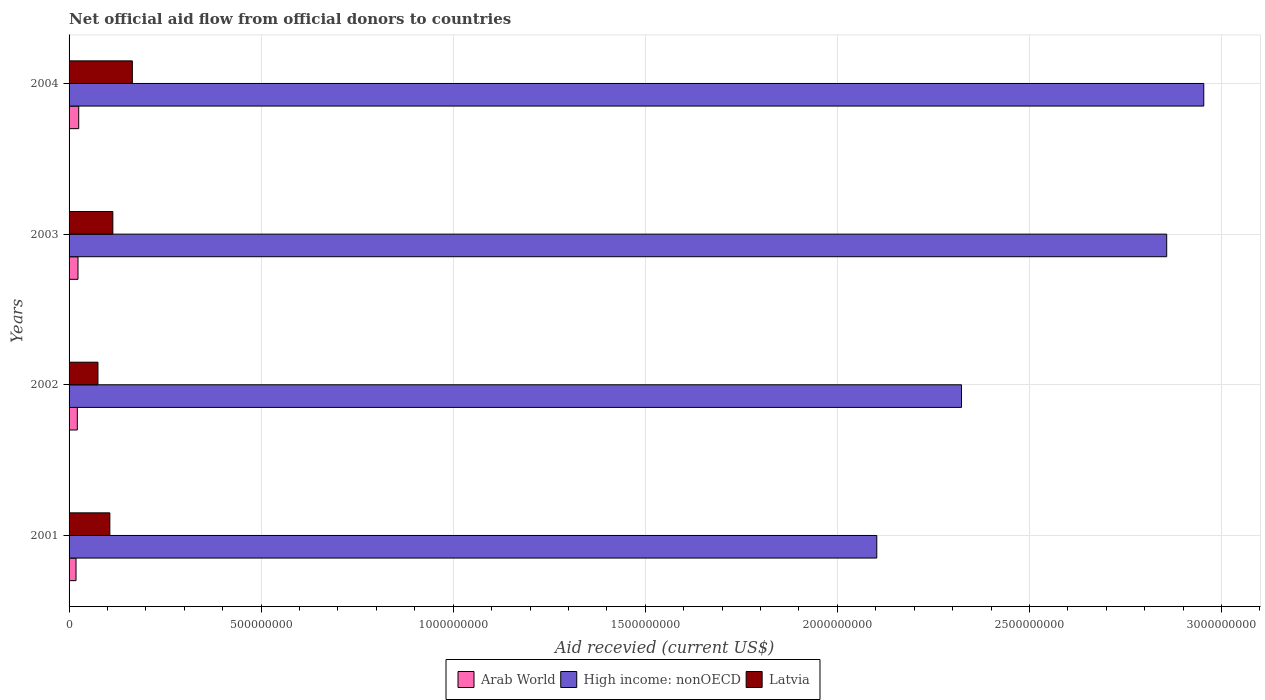How many groups of bars are there?
Provide a succinct answer. 4. Are the number of bars per tick equal to the number of legend labels?
Make the answer very short. Yes. Are the number of bars on each tick of the Y-axis equal?
Your answer should be compact. Yes. How many bars are there on the 1st tick from the top?
Your answer should be compact. 3. In how many cases, is the number of bars for a given year not equal to the number of legend labels?
Ensure brevity in your answer.  0. What is the total aid received in Arab World in 2001?
Keep it short and to the point. 1.81e+07. Across all years, what is the maximum total aid received in Arab World?
Provide a short and direct response. 2.51e+07. Across all years, what is the minimum total aid received in Latvia?
Provide a succinct answer. 7.52e+07. In which year was the total aid received in Arab World minimum?
Your answer should be very brief. 2001. What is the total total aid received in High income: nonOECD in the graph?
Offer a very short reply. 1.02e+1. What is the difference between the total aid received in Arab World in 2003 and that in 2004?
Your answer should be compact. -1.86e+06. What is the difference between the total aid received in High income: nonOECD in 2001 and the total aid received in Arab World in 2003?
Offer a terse response. 2.08e+09. What is the average total aid received in Arab World per year?
Keep it short and to the point. 2.20e+07. In the year 2004, what is the difference between the total aid received in High income: nonOECD and total aid received in Latvia?
Offer a very short reply. 2.79e+09. What is the ratio of the total aid received in Latvia in 2003 to that in 2004?
Ensure brevity in your answer.  0.69. Is the total aid received in Latvia in 2001 less than that in 2003?
Provide a succinct answer. Yes. What is the difference between the highest and the second highest total aid received in Arab World?
Keep it short and to the point. 1.86e+06. What is the difference between the highest and the lowest total aid received in High income: nonOECD?
Your answer should be very brief. 8.51e+08. Is the sum of the total aid received in Latvia in 2001 and 2004 greater than the maximum total aid received in High income: nonOECD across all years?
Your answer should be compact. No. What does the 2nd bar from the top in 2002 represents?
Make the answer very short. High income: nonOECD. What does the 1st bar from the bottom in 2004 represents?
Offer a very short reply. Arab World. How many bars are there?
Keep it short and to the point. 12. Where does the legend appear in the graph?
Your answer should be compact. Bottom center. How many legend labels are there?
Ensure brevity in your answer.  3. What is the title of the graph?
Give a very brief answer. Net official aid flow from official donors to countries. What is the label or title of the X-axis?
Keep it short and to the point. Aid recevied (current US$). What is the Aid recevied (current US$) in Arab World in 2001?
Offer a terse response. 1.81e+07. What is the Aid recevied (current US$) of High income: nonOECD in 2001?
Offer a very short reply. 2.10e+09. What is the Aid recevied (current US$) of Latvia in 2001?
Your answer should be very brief. 1.06e+08. What is the Aid recevied (current US$) of Arab World in 2002?
Ensure brevity in your answer.  2.14e+07. What is the Aid recevied (current US$) in High income: nonOECD in 2002?
Make the answer very short. 2.32e+09. What is the Aid recevied (current US$) of Latvia in 2002?
Your answer should be compact. 7.52e+07. What is the Aid recevied (current US$) in Arab World in 2003?
Give a very brief answer. 2.32e+07. What is the Aid recevied (current US$) of High income: nonOECD in 2003?
Provide a short and direct response. 2.86e+09. What is the Aid recevied (current US$) of Latvia in 2003?
Offer a very short reply. 1.14e+08. What is the Aid recevied (current US$) in Arab World in 2004?
Offer a very short reply. 2.51e+07. What is the Aid recevied (current US$) in High income: nonOECD in 2004?
Provide a short and direct response. 2.95e+09. What is the Aid recevied (current US$) in Latvia in 2004?
Your response must be concise. 1.65e+08. Across all years, what is the maximum Aid recevied (current US$) in Arab World?
Offer a very short reply. 2.51e+07. Across all years, what is the maximum Aid recevied (current US$) in High income: nonOECD?
Provide a short and direct response. 2.95e+09. Across all years, what is the maximum Aid recevied (current US$) of Latvia?
Keep it short and to the point. 1.65e+08. Across all years, what is the minimum Aid recevied (current US$) in Arab World?
Your response must be concise. 1.81e+07. Across all years, what is the minimum Aid recevied (current US$) in High income: nonOECD?
Your response must be concise. 2.10e+09. Across all years, what is the minimum Aid recevied (current US$) of Latvia?
Give a very brief answer. 7.52e+07. What is the total Aid recevied (current US$) in Arab World in the graph?
Give a very brief answer. 8.79e+07. What is the total Aid recevied (current US$) of High income: nonOECD in the graph?
Provide a succinct answer. 1.02e+1. What is the total Aid recevied (current US$) in Latvia in the graph?
Your answer should be compact. 4.60e+08. What is the difference between the Aid recevied (current US$) of Arab World in 2001 and that in 2002?
Offer a very short reply. -3.33e+06. What is the difference between the Aid recevied (current US$) of High income: nonOECD in 2001 and that in 2002?
Offer a very short reply. -2.21e+08. What is the difference between the Aid recevied (current US$) of Latvia in 2001 and that in 2002?
Keep it short and to the point. 3.09e+07. What is the difference between the Aid recevied (current US$) of Arab World in 2001 and that in 2003?
Offer a very short reply. -5.14e+06. What is the difference between the Aid recevied (current US$) of High income: nonOECD in 2001 and that in 2003?
Offer a terse response. -7.55e+08. What is the difference between the Aid recevied (current US$) in Latvia in 2001 and that in 2003?
Your answer should be very brief. -7.80e+06. What is the difference between the Aid recevied (current US$) of Arab World in 2001 and that in 2004?
Your answer should be very brief. -7.00e+06. What is the difference between the Aid recevied (current US$) of High income: nonOECD in 2001 and that in 2004?
Offer a very short reply. -8.51e+08. What is the difference between the Aid recevied (current US$) in Latvia in 2001 and that in 2004?
Your response must be concise. -5.86e+07. What is the difference between the Aid recevied (current US$) of Arab World in 2002 and that in 2003?
Provide a short and direct response. -1.81e+06. What is the difference between the Aid recevied (current US$) of High income: nonOECD in 2002 and that in 2003?
Provide a short and direct response. -5.34e+08. What is the difference between the Aid recevied (current US$) in Latvia in 2002 and that in 2003?
Make the answer very short. -3.87e+07. What is the difference between the Aid recevied (current US$) of Arab World in 2002 and that in 2004?
Give a very brief answer. -3.67e+06. What is the difference between the Aid recevied (current US$) in High income: nonOECD in 2002 and that in 2004?
Make the answer very short. -6.31e+08. What is the difference between the Aid recevied (current US$) of Latvia in 2002 and that in 2004?
Provide a short and direct response. -8.95e+07. What is the difference between the Aid recevied (current US$) in Arab World in 2003 and that in 2004?
Offer a terse response. -1.86e+06. What is the difference between the Aid recevied (current US$) of High income: nonOECD in 2003 and that in 2004?
Your answer should be compact. -9.65e+07. What is the difference between the Aid recevied (current US$) of Latvia in 2003 and that in 2004?
Your response must be concise. -5.08e+07. What is the difference between the Aid recevied (current US$) in Arab World in 2001 and the Aid recevied (current US$) in High income: nonOECD in 2002?
Ensure brevity in your answer.  -2.31e+09. What is the difference between the Aid recevied (current US$) of Arab World in 2001 and the Aid recevied (current US$) of Latvia in 2002?
Provide a short and direct response. -5.71e+07. What is the difference between the Aid recevied (current US$) of High income: nonOECD in 2001 and the Aid recevied (current US$) of Latvia in 2002?
Your response must be concise. 2.03e+09. What is the difference between the Aid recevied (current US$) of Arab World in 2001 and the Aid recevied (current US$) of High income: nonOECD in 2003?
Offer a very short reply. -2.84e+09. What is the difference between the Aid recevied (current US$) of Arab World in 2001 and the Aid recevied (current US$) of Latvia in 2003?
Ensure brevity in your answer.  -9.58e+07. What is the difference between the Aid recevied (current US$) of High income: nonOECD in 2001 and the Aid recevied (current US$) of Latvia in 2003?
Keep it short and to the point. 1.99e+09. What is the difference between the Aid recevied (current US$) of Arab World in 2001 and the Aid recevied (current US$) of High income: nonOECD in 2004?
Ensure brevity in your answer.  -2.94e+09. What is the difference between the Aid recevied (current US$) of Arab World in 2001 and the Aid recevied (current US$) of Latvia in 2004?
Ensure brevity in your answer.  -1.47e+08. What is the difference between the Aid recevied (current US$) of High income: nonOECD in 2001 and the Aid recevied (current US$) of Latvia in 2004?
Your answer should be very brief. 1.94e+09. What is the difference between the Aid recevied (current US$) of Arab World in 2002 and the Aid recevied (current US$) of High income: nonOECD in 2003?
Give a very brief answer. -2.84e+09. What is the difference between the Aid recevied (current US$) of Arab World in 2002 and the Aid recevied (current US$) of Latvia in 2003?
Provide a short and direct response. -9.25e+07. What is the difference between the Aid recevied (current US$) of High income: nonOECD in 2002 and the Aid recevied (current US$) of Latvia in 2003?
Your response must be concise. 2.21e+09. What is the difference between the Aid recevied (current US$) in Arab World in 2002 and the Aid recevied (current US$) in High income: nonOECD in 2004?
Ensure brevity in your answer.  -2.93e+09. What is the difference between the Aid recevied (current US$) of Arab World in 2002 and the Aid recevied (current US$) of Latvia in 2004?
Your response must be concise. -1.43e+08. What is the difference between the Aid recevied (current US$) in High income: nonOECD in 2002 and the Aid recevied (current US$) in Latvia in 2004?
Provide a succinct answer. 2.16e+09. What is the difference between the Aid recevied (current US$) in Arab World in 2003 and the Aid recevied (current US$) in High income: nonOECD in 2004?
Make the answer very short. -2.93e+09. What is the difference between the Aid recevied (current US$) in Arab World in 2003 and the Aid recevied (current US$) in Latvia in 2004?
Offer a terse response. -1.41e+08. What is the difference between the Aid recevied (current US$) in High income: nonOECD in 2003 and the Aid recevied (current US$) in Latvia in 2004?
Keep it short and to the point. 2.69e+09. What is the average Aid recevied (current US$) in Arab World per year?
Offer a terse response. 2.20e+07. What is the average Aid recevied (current US$) of High income: nonOECD per year?
Give a very brief answer. 2.56e+09. What is the average Aid recevied (current US$) of Latvia per year?
Provide a succinct answer. 1.15e+08. In the year 2001, what is the difference between the Aid recevied (current US$) of Arab World and Aid recevied (current US$) of High income: nonOECD?
Your response must be concise. -2.08e+09. In the year 2001, what is the difference between the Aid recevied (current US$) in Arab World and Aid recevied (current US$) in Latvia?
Your answer should be very brief. -8.80e+07. In the year 2001, what is the difference between the Aid recevied (current US$) of High income: nonOECD and Aid recevied (current US$) of Latvia?
Provide a succinct answer. 2.00e+09. In the year 2002, what is the difference between the Aid recevied (current US$) in Arab World and Aid recevied (current US$) in High income: nonOECD?
Offer a terse response. -2.30e+09. In the year 2002, what is the difference between the Aid recevied (current US$) in Arab World and Aid recevied (current US$) in Latvia?
Ensure brevity in your answer.  -5.38e+07. In the year 2002, what is the difference between the Aid recevied (current US$) of High income: nonOECD and Aid recevied (current US$) of Latvia?
Offer a very short reply. 2.25e+09. In the year 2003, what is the difference between the Aid recevied (current US$) of Arab World and Aid recevied (current US$) of High income: nonOECD?
Provide a short and direct response. -2.83e+09. In the year 2003, what is the difference between the Aid recevied (current US$) in Arab World and Aid recevied (current US$) in Latvia?
Give a very brief answer. -9.07e+07. In the year 2003, what is the difference between the Aid recevied (current US$) of High income: nonOECD and Aid recevied (current US$) of Latvia?
Give a very brief answer. 2.74e+09. In the year 2004, what is the difference between the Aid recevied (current US$) of Arab World and Aid recevied (current US$) of High income: nonOECD?
Keep it short and to the point. -2.93e+09. In the year 2004, what is the difference between the Aid recevied (current US$) in Arab World and Aid recevied (current US$) in Latvia?
Your response must be concise. -1.40e+08. In the year 2004, what is the difference between the Aid recevied (current US$) of High income: nonOECD and Aid recevied (current US$) of Latvia?
Your answer should be compact. 2.79e+09. What is the ratio of the Aid recevied (current US$) of Arab World in 2001 to that in 2002?
Your answer should be very brief. 0.84. What is the ratio of the Aid recevied (current US$) in High income: nonOECD in 2001 to that in 2002?
Make the answer very short. 0.91. What is the ratio of the Aid recevied (current US$) of Latvia in 2001 to that in 2002?
Your response must be concise. 1.41. What is the ratio of the Aid recevied (current US$) of Arab World in 2001 to that in 2003?
Your response must be concise. 0.78. What is the ratio of the Aid recevied (current US$) in High income: nonOECD in 2001 to that in 2003?
Provide a short and direct response. 0.74. What is the ratio of the Aid recevied (current US$) of Latvia in 2001 to that in 2003?
Provide a short and direct response. 0.93. What is the ratio of the Aid recevied (current US$) in Arab World in 2001 to that in 2004?
Provide a succinct answer. 0.72. What is the ratio of the Aid recevied (current US$) of High income: nonOECD in 2001 to that in 2004?
Your answer should be very brief. 0.71. What is the ratio of the Aid recevied (current US$) of Latvia in 2001 to that in 2004?
Give a very brief answer. 0.64. What is the ratio of the Aid recevied (current US$) in Arab World in 2002 to that in 2003?
Provide a succinct answer. 0.92. What is the ratio of the Aid recevied (current US$) of High income: nonOECD in 2002 to that in 2003?
Offer a terse response. 0.81. What is the ratio of the Aid recevied (current US$) in Latvia in 2002 to that in 2003?
Your answer should be compact. 0.66. What is the ratio of the Aid recevied (current US$) of Arab World in 2002 to that in 2004?
Your answer should be compact. 0.85. What is the ratio of the Aid recevied (current US$) in High income: nonOECD in 2002 to that in 2004?
Your response must be concise. 0.79. What is the ratio of the Aid recevied (current US$) in Latvia in 2002 to that in 2004?
Your answer should be very brief. 0.46. What is the ratio of the Aid recevied (current US$) in Arab World in 2003 to that in 2004?
Give a very brief answer. 0.93. What is the ratio of the Aid recevied (current US$) of High income: nonOECD in 2003 to that in 2004?
Offer a very short reply. 0.97. What is the ratio of the Aid recevied (current US$) of Latvia in 2003 to that in 2004?
Provide a short and direct response. 0.69. What is the difference between the highest and the second highest Aid recevied (current US$) in Arab World?
Your answer should be compact. 1.86e+06. What is the difference between the highest and the second highest Aid recevied (current US$) of High income: nonOECD?
Your answer should be very brief. 9.65e+07. What is the difference between the highest and the second highest Aid recevied (current US$) of Latvia?
Make the answer very short. 5.08e+07. What is the difference between the highest and the lowest Aid recevied (current US$) in High income: nonOECD?
Offer a very short reply. 8.51e+08. What is the difference between the highest and the lowest Aid recevied (current US$) in Latvia?
Provide a short and direct response. 8.95e+07. 